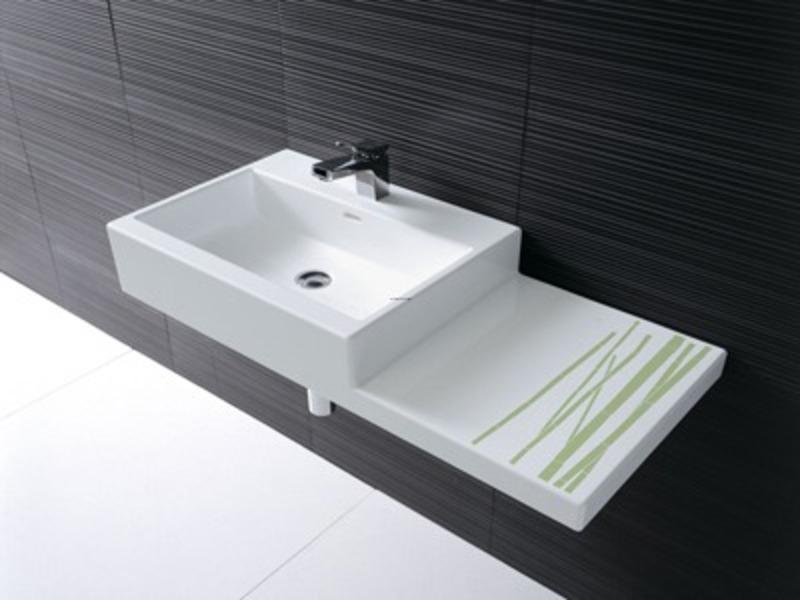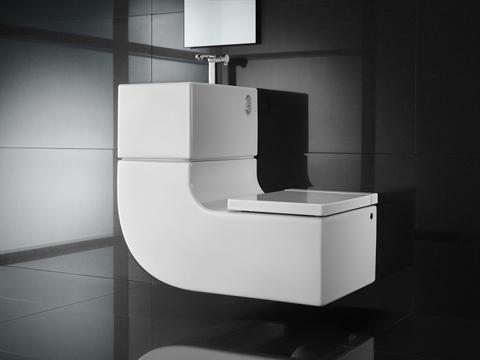The first image is the image on the left, the second image is the image on the right. Analyze the images presented: Is the assertion "A thin stream of water is flowing into a sink that sits atop a dark wood counter in one image." valid? Answer yes or no. No. The first image is the image on the left, the second image is the image on the right. Given the left and right images, does the statement "A round mirror is above a sink." hold true? Answer yes or no. No. 